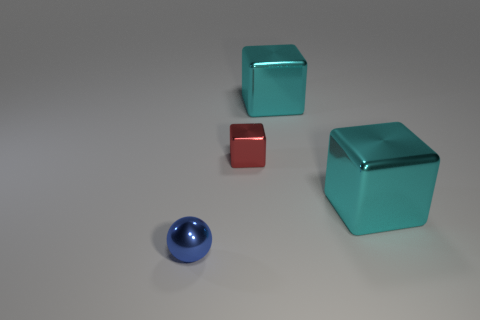Subtract all cyan metal cubes. How many cubes are left? 1 Subtract all blocks. How many objects are left? 1 Subtract 2 cubes. How many cubes are left? 1 Add 3 tiny blue things. How many tiny blue things are left? 4 Add 2 shiny cubes. How many shiny cubes exist? 5 Add 2 cyan things. How many objects exist? 6 Subtract all red blocks. How many blocks are left? 2 Subtract 0 red balls. How many objects are left? 4 Subtract all yellow cubes. Subtract all blue balls. How many cubes are left? 3 Subtract all cyan cylinders. How many cyan cubes are left? 2 